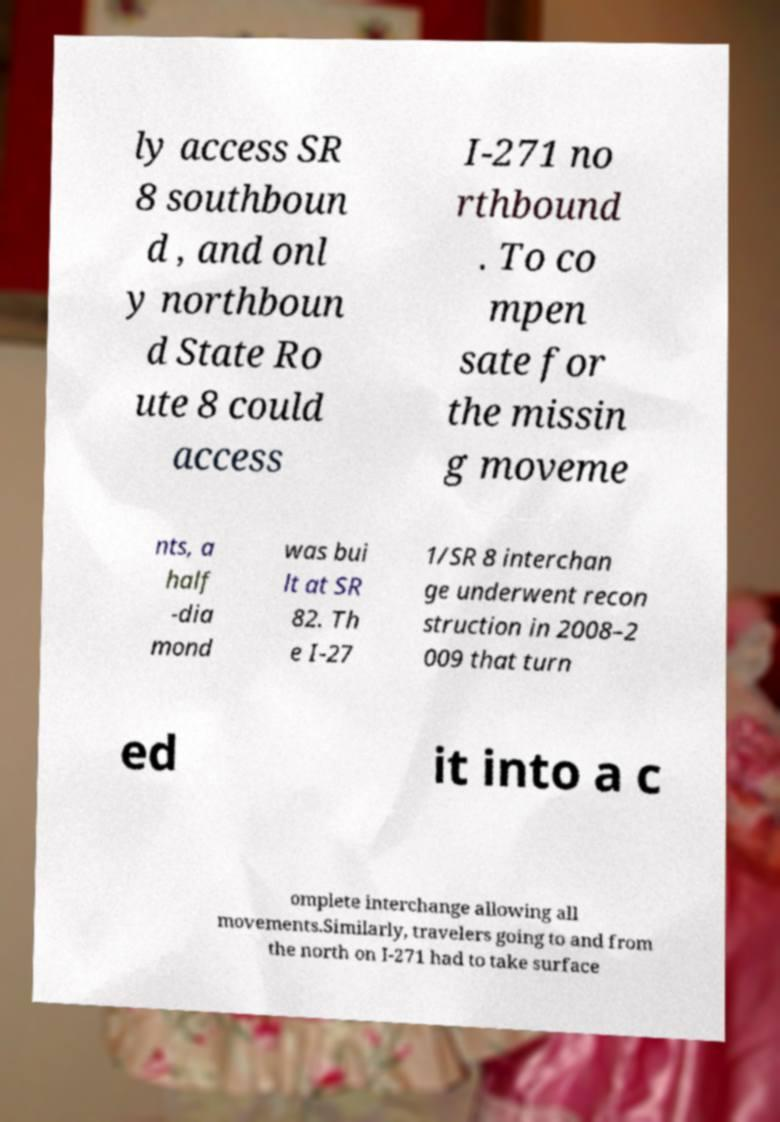I need the written content from this picture converted into text. Can you do that? ly access SR 8 southboun d , and onl y northboun d State Ro ute 8 could access I-271 no rthbound . To co mpen sate for the missin g moveme nts, a half -dia mond was bui lt at SR 82. Th e I-27 1/SR 8 interchan ge underwent recon struction in 2008–2 009 that turn ed it into a c omplete interchange allowing all movements.Similarly, travelers going to and from the north on I-271 had to take surface 